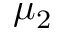Convert formula to latex. <formula><loc_0><loc_0><loc_500><loc_500>\mu _ { 2 }</formula> 